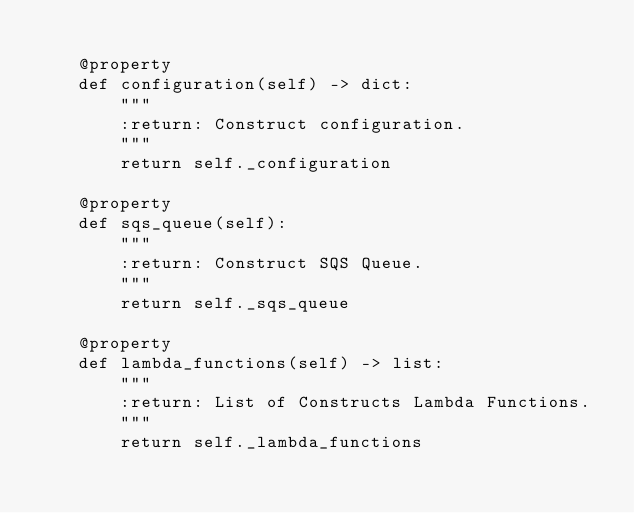Convert code to text. <code><loc_0><loc_0><loc_500><loc_500><_Python_>
    @property
    def configuration(self) -> dict:
        """
        :return: Construct configuration.
        """
        return self._configuration

    @property
    def sqs_queue(self):
        """
        :return: Construct SQS Queue.
        """
        return self._sqs_queue

    @property
    def lambda_functions(self) -> list:
        """
        :return: List of Constructs Lambda Functions.
        """
        return self._lambda_functions
</code> 